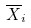Convert formula to latex. <formula><loc_0><loc_0><loc_500><loc_500>\overline { X } _ { i }</formula> 